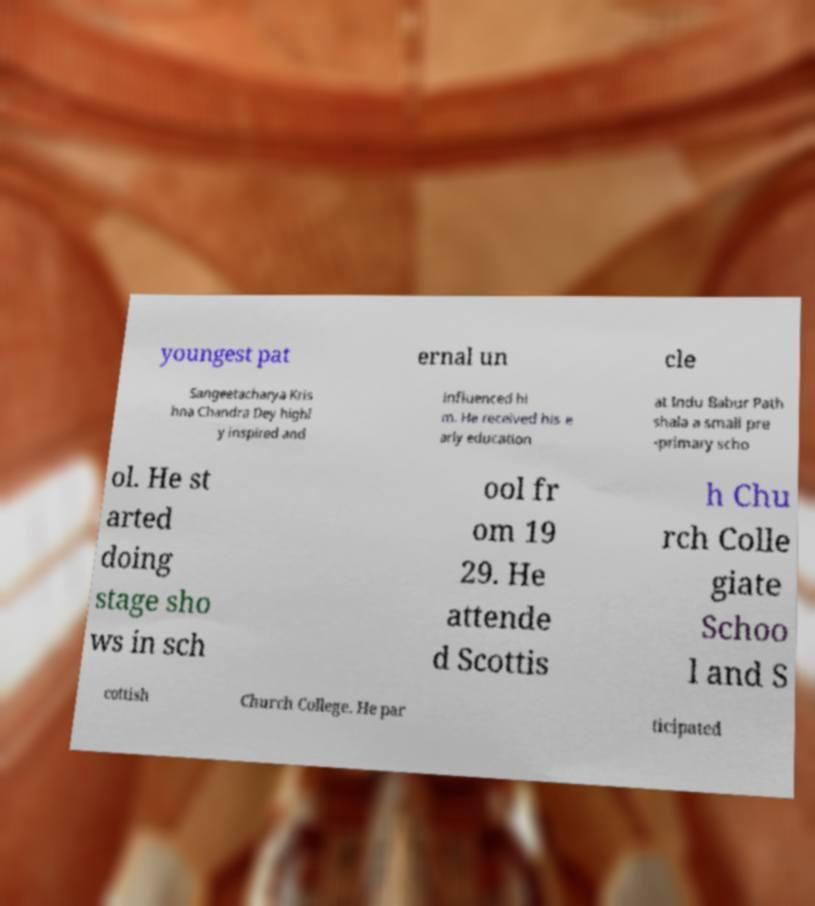For documentation purposes, I need the text within this image transcribed. Could you provide that? youngest pat ernal un cle Sangeetacharya Kris hna Chandra Dey highl y inspired and influenced hi m. He received his e arly education at Indu Babur Path shala a small pre -primary scho ol. He st arted doing stage sho ws in sch ool fr om 19 29. He attende d Scottis h Chu rch Colle giate Schoo l and S cottish Church College. He par ticipated 